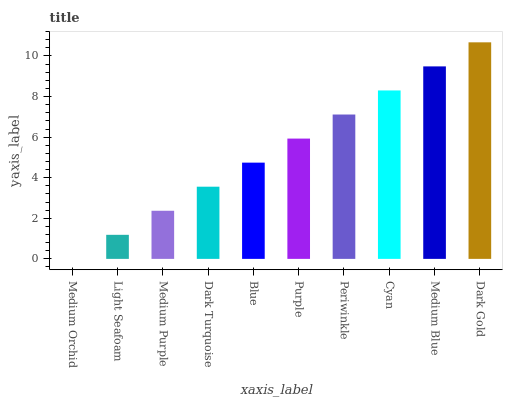Is Medium Orchid the minimum?
Answer yes or no. Yes. Is Dark Gold the maximum?
Answer yes or no. Yes. Is Light Seafoam the minimum?
Answer yes or no. No. Is Light Seafoam the maximum?
Answer yes or no. No. Is Light Seafoam greater than Medium Orchid?
Answer yes or no. Yes. Is Medium Orchid less than Light Seafoam?
Answer yes or no. Yes. Is Medium Orchid greater than Light Seafoam?
Answer yes or no. No. Is Light Seafoam less than Medium Orchid?
Answer yes or no. No. Is Purple the high median?
Answer yes or no. Yes. Is Blue the low median?
Answer yes or no. Yes. Is Dark Turquoise the high median?
Answer yes or no. No. Is Dark Turquoise the low median?
Answer yes or no. No. 